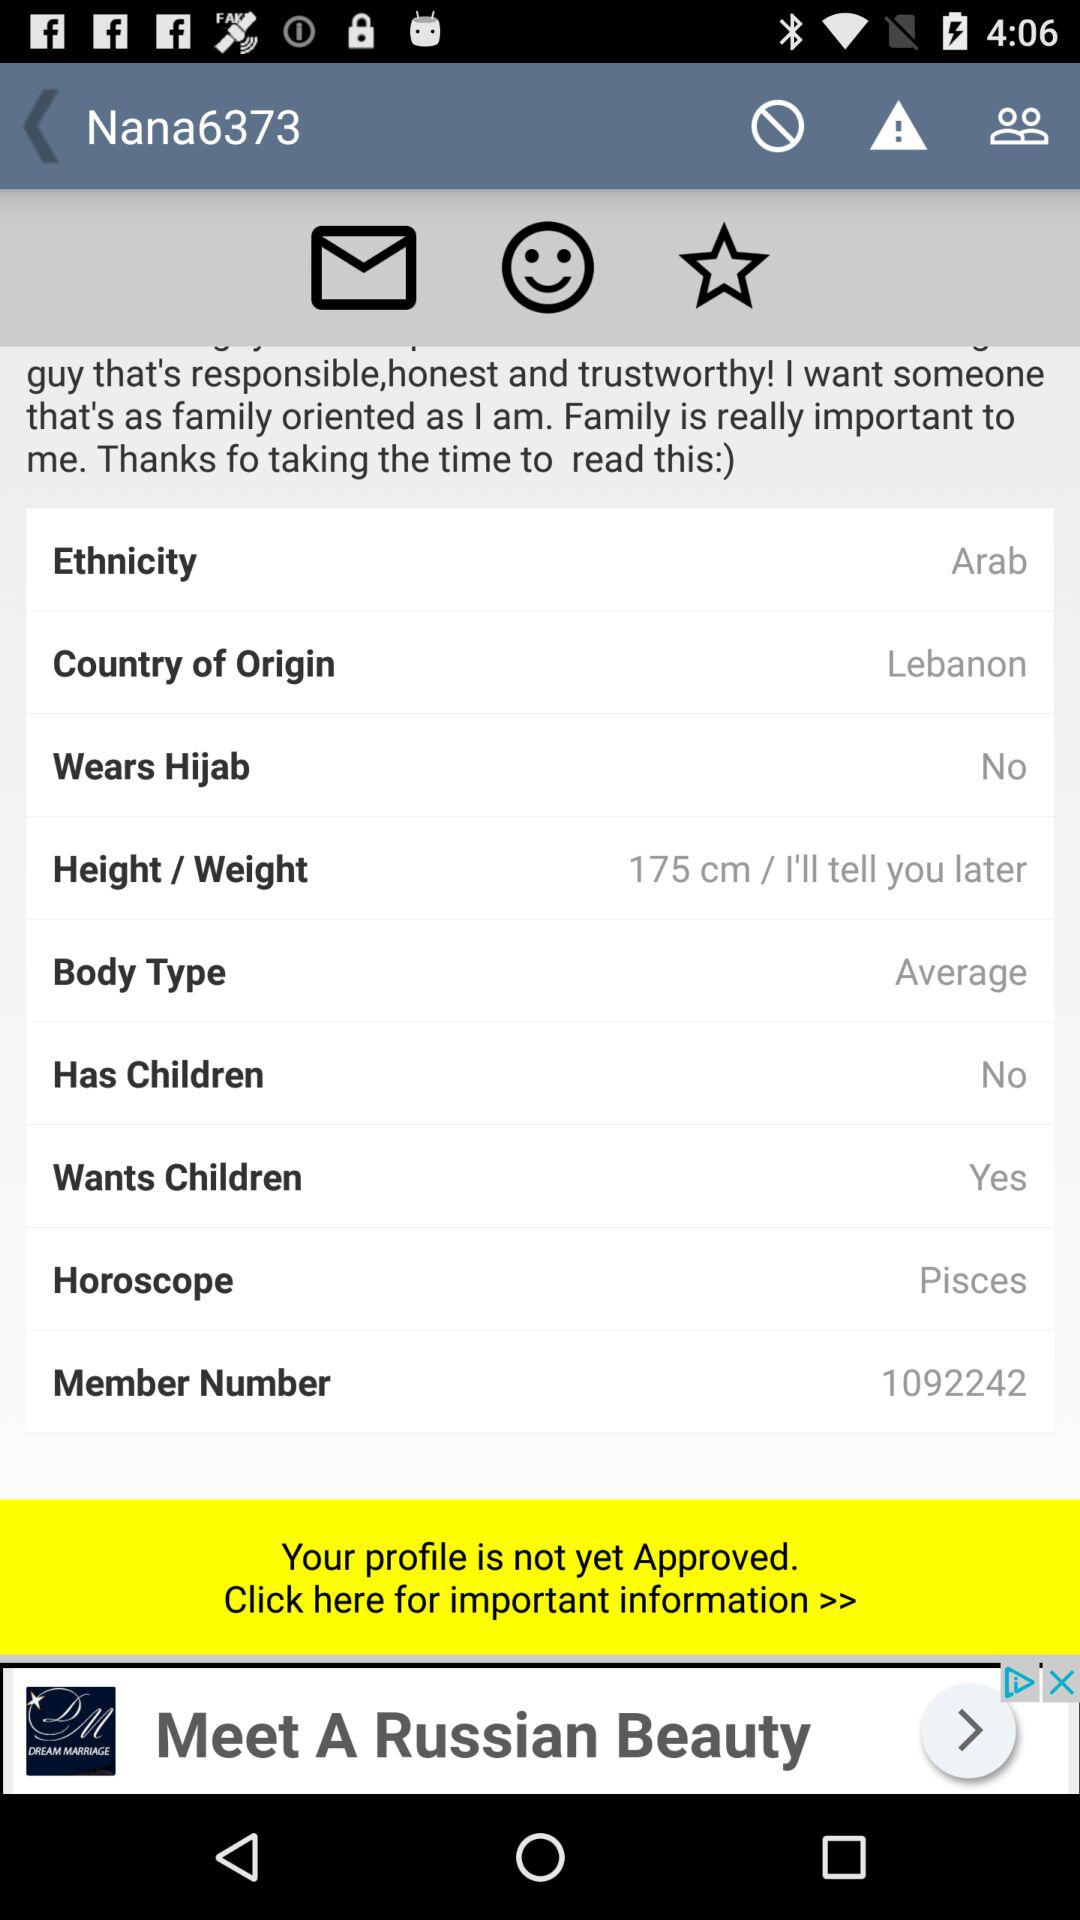What are the names of the user's children?
When the provided information is insufficient, respond with <no answer>. <no answer> 